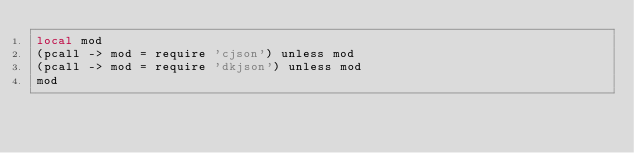Convert code to text. <code><loc_0><loc_0><loc_500><loc_500><_MoonScript_>local mod
(pcall -> mod = require 'cjson') unless mod
(pcall -> mod = require 'dkjson') unless mod
mod
</code> 